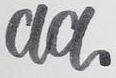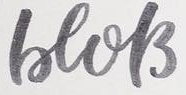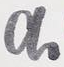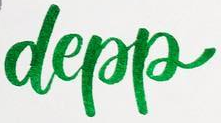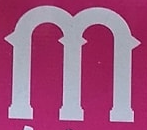Identify the words shown in these images in order, separated by a semicolon. aa; beols; a; depp; m 